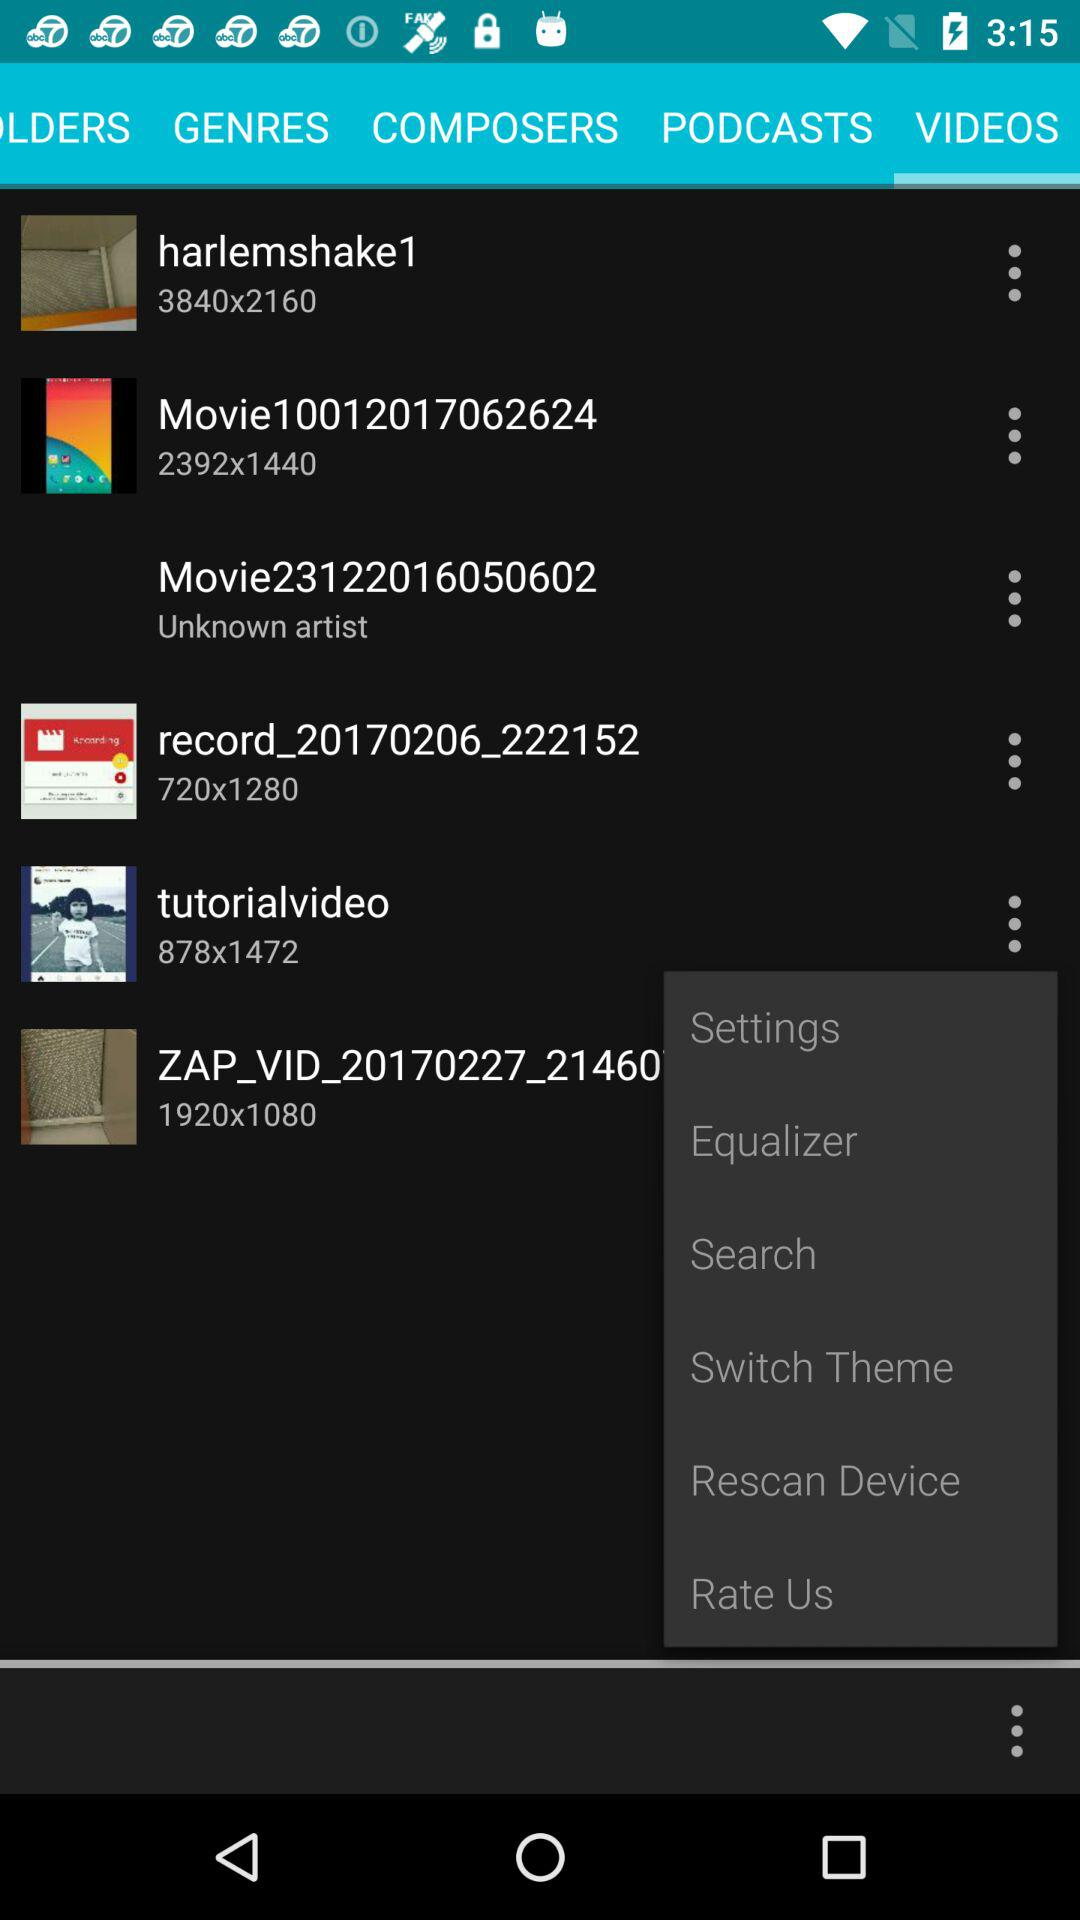What is the video ZAP_VID's pixel size? The pixel size of ZAP_VID is 1920x1080. 